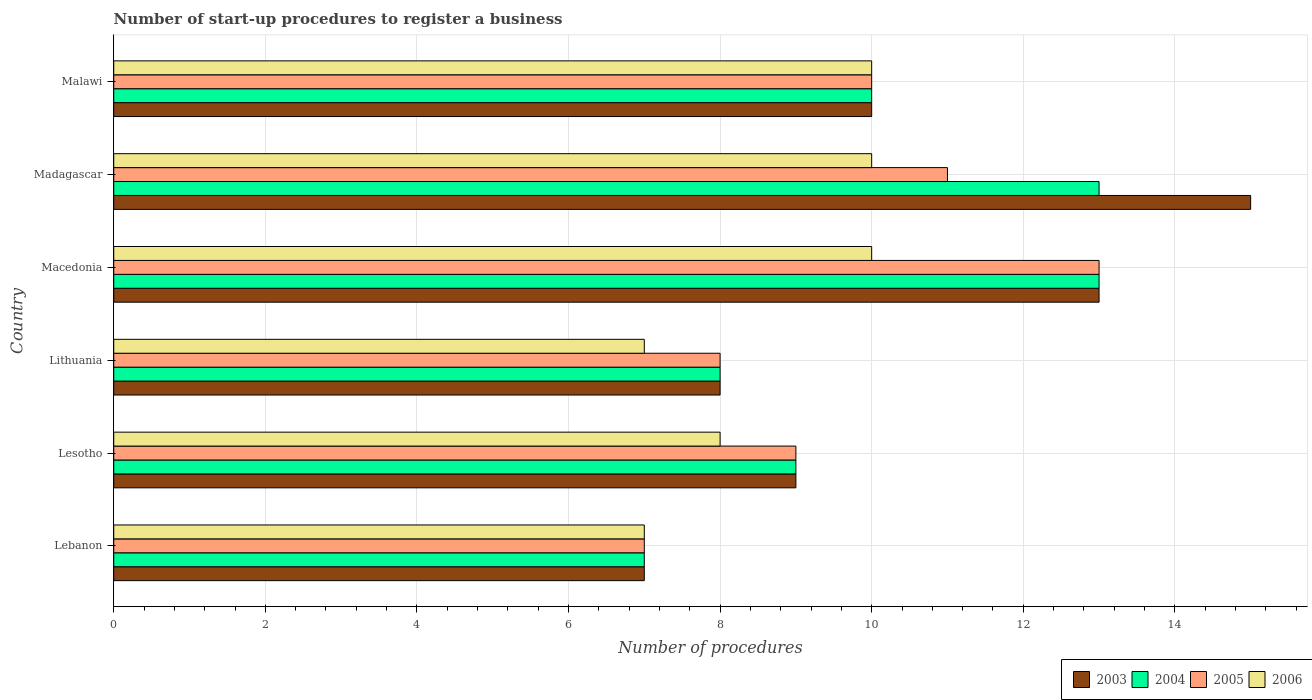How many groups of bars are there?
Your answer should be compact. 6. Are the number of bars per tick equal to the number of legend labels?
Give a very brief answer. Yes. How many bars are there on the 3rd tick from the top?
Your response must be concise. 4. How many bars are there on the 2nd tick from the bottom?
Give a very brief answer. 4. What is the label of the 3rd group of bars from the top?
Give a very brief answer. Macedonia. In how many cases, is the number of bars for a given country not equal to the number of legend labels?
Your response must be concise. 0. Across all countries, what is the minimum number of procedures required to register a business in 2005?
Offer a terse response. 7. In which country was the number of procedures required to register a business in 2005 maximum?
Keep it short and to the point. Macedonia. In which country was the number of procedures required to register a business in 2003 minimum?
Your answer should be very brief. Lebanon. What is the difference between the number of procedures required to register a business in 2003 in Lithuania and that in Madagascar?
Give a very brief answer. -7. What is the average number of procedures required to register a business in 2005 per country?
Provide a succinct answer. 9.67. What is the ratio of the number of procedures required to register a business in 2004 in Macedonia to that in Madagascar?
Ensure brevity in your answer.  1. Is the number of procedures required to register a business in 2004 in Lebanon less than that in Madagascar?
Give a very brief answer. Yes. Is the difference between the number of procedures required to register a business in 2004 in Lithuania and Macedonia greater than the difference between the number of procedures required to register a business in 2005 in Lithuania and Macedonia?
Ensure brevity in your answer.  No. What is the difference between the highest and the lowest number of procedures required to register a business in 2006?
Your answer should be compact. 3. Is the sum of the number of procedures required to register a business in 2004 in Lebanon and Macedonia greater than the maximum number of procedures required to register a business in 2005 across all countries?
Keep it short and to the point. Yes. What does the 2nd bar from the bottom in Lithuania represents?
Make the answer very short. 2004. Is it the case that in every country, the sum of the number of procedures required to register a business in 2005 and number of procedures required to register a business in 2004 is greater than the number of procedures required to register a business in 2006?
Give a very brief answer. Yes. Are all the bars in the graph horizontal?
Offer a terse response. Yes. What is the difference between two consecutive major ticks on the X-axis?
Offer a very short reply. 2. How are the legend labels stacked?
Ensure brevity in your answer.  Horizontal. What is the title of the graph?
Keep it short and to the point. Number of start-up procedures to register a business. What is the label or title of the X-axis?
Ensure brevity in your answer.  Number of procedures. What is the Number of procedures in 2004 in Lebanon?
Provide a succinct answer. 7. What is the Number of procedures of 2005 in Lebanon?
Your answer should be compact. 7. What is the Number of procedures of 2006 in Lebanon?
Provide a succinct answer. 7. What is the Number of procedures of 2006 in Lesotho?
Offer a terse response. 8. What is the Number of procedures of 2003 in Lithuania?
Provide a short and direct response. 8. What is the Number of procedures in 2006 in Lithuania?
Give a very brief answer. 7. What is the Number of procedures in 2004 in Macedonia?
Your answer should be compact. 13. What is the Number of procedures in 2005 in Macedonia?
Provide a succinct answer. 13. What is the Number of procedures in 2004 in Madagascar?
Ensure brevity in your answer.  13. What is the Number of procedures of 2005 in Malawi?
Ensure brevity in your answer.  10. Across all countries, what is the maximum Number of procedures in 2003?
Ensure brevity in your answer.  15. Across all countries, what is the maximum Number of procedures of 2004?
Ensure brevity in your answer.  13. Across all countries, what is the maximum Number of procedures in 2006?
Offer a terse response. 10. Across all countries, what is the minimum Number of procedures in 2003?
Your response must be concise. 7. Across all countries, what is the minimum Number of procedures in 2004?
Give a very brief answer. 7. Across all countries, what is the minimum Number of procedures of 2006?
Provide a succinct answer. 7. What is the total Number of procedures of 2004 in the graph?
Offer a very short reply. 60. What is the total Number of procedures of 2005 in the graph?
Ensure brevity in your answer.  58. What is the total Number of procedures in 2006 in the graph?
Ensure brevity in your answer.  52. What is the difference between the Number of procedures of 2003 in Lebanon and that in Lesotho?
Make the answer very short. -2. What is the difference between the Number of procedures of 2005 in Lebanon and that in Lesotho?
Provide a succinct answer. -2. What is the difference between the Number of procedures in 2006 in Lebanon and that in Lesotho?
Your response must be concise. -1. What is the difference between the Number of procedures of 2004 in Lebanon and that in Lithuania?
Keep it short and to the point. -1. What is the difference between the Number of procedures of 2005 in Lebanon and that in Lithuania?
Make the answer very short. -1. What is the difference between the Number of procedures of 2006 in Lebanon and that in Lithuania?
Offer a terse response. 0. What is the difference between the Number of procedures of 2003 in Lebanon and that in Macedonia?
Your answer should be very brief. -6. What is the difference between the Number of procedures in 2004 in Lebanon and that in Macedonia?
Offer a very short reply. -6. What is the difference between the Number of procedures in 2003 in Lebanon and that in Madagascar?
Make the answer very short. -8. What is the difference between the Number of procedures in 2005 in Lebanon and that in Madagascar?
Make the answer very short. -4. What is the difference between the Number of procedures of 2006 in Lebanon and that in Madagascar?
Provide a short and direct response. -3. What is the difference between the Number of procedures of 2003 in Lebanon and that in Malawi?
Keep it short and to the point. -3. What is the difference between the Number of procedures of 2003 in Lesotho and that in Lithuania?
Provide a short and direct response. 1. What is the difference between the Number of procedures of 2003 in Lesotho and that in Macedonia?
Keep it short and to the point. -4. What is the difference between the Number of procedures of 2004 in Lesotho and that in Macedonia?
Give a very brief answer. -4. What is the difference between the Number of procedures in 2005 in Lesotho and that in Macedonia?
Your answer should be very brief. -4. What is the difference between the Number of procedures in 2006 in Lesotho and that in Macedonia?
Offer a terse response. -2. What is the difference between the Number of procedures of 2003 in Lesotho and that in Madagascar?
Your answer should be very brief. -6. What is the difference between the Number of procedures of 2004 in Lesotho and that in Madagascar?
Provide a short and direct response. -4. What is the difference between the Number of procedures in 2005 in Lesotho and that in Madagascar?
Ensure brevity in your answer.  -2. What is the difference between the Number of procedures of 2004 in Lesotho and that in Malawi?
Keep it short and to the point. -1. What is the difference between the Number of procedures of 2003 in Lithuania and that in Macedonia?
Provide a short and direct response. -5. What is the difference between the Number of procedures in 2004 in Lithuania and that in Macedonia?
Offer a very short reply. -5. What is the difference between the Number of procedures of 2003 in Lithuania and that in Madagascar?
Make the answer very short. -7. What is the difference between the Number of procedures of 2004 in Lithuania and that in Madagascar?
Keep it short and to the point. -5. What is the difference between the Number of procedures of 2005 in Lithuania and that in Madagascar?
Make the answer very short. -3. What is the difference between the Number of procedures of 2006 in Lithuania and that in Madagascar?
Your response must be concise. -3. What is the difference between the Number of procedures of 2003 in Lithuania and that in Malawi?
Provide a short and direct response. -2. What is the difference between the Number of procedures in 2004 in Lithuania and that in Malawi?
Provide a succinct answer. -2. What is the difference between the Number of procedures in 2005 in Lithuania and that in Malawi?
Your answer should be compact. -2. What is the difference between the Number of procedures in 2006 in Lithuania and that in Malawi?
Offer a very short reply. -3. What is the difference between the Number of procedures of 2005 in Macedonia and that in Madagascar?
Your answer should be compact. 2. What is the difference between the Number of procedures in 2004 in Macedonia and that in Malawi?
Offer a very short reply. 3. What is the difference between the Number of procedures of 2006 in Macedonia and that in Malawi?
Make the answer very short. 0. What is the difference between the Number of procedures in 2004 in Madagascar and that in Malawi?
Ensure brevity in your answer.  3. What is the difference between the Number of procedures in 2006 in Madagascar and that in Malawi?
Make the answer very short. 0. What is the difference between the Number of procedures in 2003 in Lebanon and the Number of procedures in 2005 in Lesotho?
Give a very brief answer. -2. What is the difference between the Number of procedures in 2005 in Lebanon and the Number of procedures in 2006 in Lesotho?
Provide a succinct answer. -1. What is the difference between the Number of procedures in 2003 in Lebanon and the Number of procedures in 2004 in Lithuania?
Your response must be concise. -1. What is the difference between the Number of procedures of 2003 in Lebanon and the Number of procedures of 2005 in Lithuania?
Ensure brevity in your answer.  -1. What is the difference between the Number of procedures of 2004 in Lebanon and the Number of procedures of 2005 in Lithuania?
Provide a succinct answer. -1. What is the difference between the Number of procedures in 2004 in Lebanon and the Number of procedures in 2006 in Macedonia?
Ensure brevity in your answer.  -3. What is the difference between the Number of procedures in 2003 in Lebanon and the Number of procedures in 2004 in Madagascar?
Your answer should be compact. -6. What is the difference between the Number of procedures in 2003 in Lebanon and the Number of procedures in 2006 in Madagascar?
Provide a succinct answer. -3. What is the difference between the Number of procedures of 2004 in Lebanon and the Number of procedures of 2006 in Madagascar?
Your answer should be compact. -3. What is the difference between the Number of procedures in 2005 in Lebanon and the Number of procedures in 2006 in Madagascar?
Provide a succinct answer. -3. What is the difference between the Number of procedures of 2003 in Lebanon and the Number of procedures of 2004 in Malawi?
Make the answer very short. -3. What is the difference between the Number of procedures of 2005 in Lebanon and the Number of procedures of 2006 in Malawi?
Give a very brief answer. -3. What is the difference between the Number of procedures in 2003 in Lesotho and the Number of procedures in 2005 in Lithuania?
Give a very brief answer. 1. What is the difference between the Number of procedures of 2003 in Lesotho and the Number of procedures of 2006 in Lithuania?
Your answer should be very brief. 2. What is the difference between the Number of procedures of 2004 in Lesotho and the Number of procedures of 2005 in Lithuania?
Give a very brief answer. 1. What is the difference between the Number of procedures in 2005 in Lesotho and the Number of procedures in 2006 in Lithuania?
Make the answer very short. 2. What is the difference between the Number of procedures of 2003 in Lesotho and the Number of procedures of 2004 in Macedonia?
Your response must be concise. -4. What is the difference between the Number of procedures in 2003 in Lesotho and the Number of procedures in 2005 in Macedonia?
Keep it short and to the point. -4. What is the difference between the Number of procedures in 2003 in Lesotho and the Number of procedures in 2006 in Macedonia?
Ensure brevity in your answer.  -1. What is the difference between the Number of procedures in 2004 in Lesotho and the Number of procedures in 2006 in Macedonia?
Give a very brief answer. -1. What is the difference between the Number of procedures of 2003 in Lesotho and the Number of procedures of 2004 in Madagascar?
Provide a short and direct response. -4. What is the difference between the Number of procedures in 2003 in Lesotho and the Number of procedures in 2005 in Madagascar?
Ensure brevity in your answer.  -2. What is the difference between the Number of procedures in 2003 in Lesotho and the Number of procedures in 2006 in Madagascar?
Your answer should be very brief. -1. What is the difference between the Number of procedures of 2003 in Lesotho and the Number of procedures of 2004 in Malawi?
Offer a very short reply. -1. What is the difference between the Number of procedures in 2003 in Lesotho and the Number of procedures in 2005 in Malawi?
Provide a succinct answer. -1. What is the difference between the Number of procedures in 2003 in Lesotho and the Number of procedures in 2006 in Malawi?
Your response must be concise. -1. What is the difference between the Number of procedures of 2003 in Lithuania and the Number of procedures of 2005 in Macedonia?
Keep it short and to the point. -5. What is the difference between the Number of procedures in 2003 in Lithuania and the Number of procedures in 2006 in Macedonia?
Give a very brief answer. -2. What is the difference between the Number of procedures in 2005 in Lithuania and the Number of procedures in 2006 in Macedonia?
Make the answer very short. -2. What is the difference between the Number of procedures in 2003 in Lithuania and the Number of procedures in 2004 in Madagascar?
Offer a terse response. -5. What is the difference between the Number of procedures of 2004 in Lithuania and the Number of procedures of 2005 in Madagascar?
Offer a very short reply. -3. What is the difference between the Number of procedures of 2005 in Lithuania and the Number of procedures of 2006 in Madagascar?
Give a very brief answer. -2. What is the difference between the Number of procedures in 2003 in Lithuania and the Number of procedures in 2005 in Malawi?
Your response must be concise. -2. What is the difference between the Number of procedures in 2003 in Lithuania and the Number of procedures in 2006 in Malawi?
Keep it short and to the point. -2. What is the difference between the Number of procedures in 2004 in Lithuania and the Number of procedures in 2005 in Malawi?
Provide a succinct answer. -2. What is the difference between the Number of procedures in 2004 in Lithuania and the Number of procedures in 2006 in Malawi?
Offer a terse response. -2. What is the difference between the Number of procedures of 2005 in Lithuania and the Number of procedures of 2006 in Malawi?
Your answer should be very brief. -2. What is the difference between the Number of procedures of 2003 in Macedonia and the Number of procedures of 2004 in Madagascar?
Your answer should be compact. 0. What is the difference between the Number of procedures of 2004 in Macedonia and the Number of procedures of 2005 in Madagascar?
Provide a short and direct response. 2. What is the difference between the Number of procedures of 2003 in Macedonia and the Number of procedures of 2006 in Malawi?
Provide a short and direct response. 3. What is the difference between the Number of procedures in 2004 in Macedonia and the Number of procedures in 2006 in Malawi?
Provide a succinct answer. 3. What is the difference between the Number of procedures of 2003 in Madagascar and the Number of procedures of 2006 in Malawi?
Keep it short and to the point. 5. What is the difference between the Number of procedures in 2005 in Madagascar and the Number of procedures in 2006 in Malawi?
Ensure brevity in your answer.  1. What is the average Number of procedures in 2003 per country?
Offer a terse response. 10.33. What is the average Number of procedures in 2004 per country?
Offer a terse response. 10. What is the average Number of procedures in 2005 per country?
Make the answer very short. 9.67. What is the average Number of procedures in 2006 per country?
Offer a terse response. 8.67. What is the difference between the Number of procedures in 2003 and Number of procedures in 2004 in Lebanon?
Your response must be concise. 0. What is the difference between the Number of procedures of 2004 and Number of procedures of 2005 in Lebanon?
Give a very brief answer. 0. What is the difference between the Number of procedures of 2004 and Number of procedures of 2006 in Lebanon?
Your answer should be compact. 0. What is the difference between the Number of procedures in 2003 and Number of procedures in 2005 in Lesotho?
Provide a short and direct response. 0. What is the difference between the Number of procedures in 2003 and Number of procedures in 2006 in Lesotho?
Your answer should be compact. 1. What is the difference between the Number of procedures of 2004 and Number of procedures of 2005 in Lesotho?
Give a very brief answer. 0. What is the difference between the Number of procedures in 2005 and Number of procedures in 2006 in Lesotho?
Ensure brevity in your answer.  1. What is the difference between the Number of procedures of 2003 and Number of procedures of 2005 in Lithuania?
Keep it short and to the point. 0. What is the difference between the Number of procedures of 2004 and Number of procedures of 2005 in Lithuania?
Ensure brevity in your answer.  0. What is the difference between the Number of procedures in 2003 and Number of procedures in 2004 in Macedonia?
Offer a terse response. 0. What is the difference between the Number of procedures of 2004 and Number of procedures of 2006 in Macedonia?
Your answer should be compact. 3. What is the difference between the Number of procedures in 2003 and Number of procedures in 2005 in Madagascar?
Offer a terse response. 4. What is the difference between the Number of procedures in 2004 and Number of procedures in 2005 in Madagascar?
Offer a very short reply. 2. What is the difference between the Number of procedures in 2004 and Number of procedures in 2006 in Madagascar?
Make the answer very short. 3. What is the difference between the Number of procedures in 2003 and Number of procedures in 2004 in Malawi?
Keep it short and to the point. 0. What is the difference between the Number of procedures in 2004 and Number of procedures in 2006 in Malawi?
Your response must be concise. 0. What is the difference between the Number of procedures in 2005 and Number of procedures in 2006 in Malawi?
Keep it short and to the point. 0. What is the ratio of the Number of procedures in 2003 in Lebanon to that in Lesotho?
Provide a short and direct response. 0.78. What is the ratio of the Number of procedures of 2003 in Lebanon to that in Lithuania?
Ensure brevity in your answer.  0.88. What is the ratio of the Number of procedures in 2004 in Lebanon to that in Lithuania?
Offer a very short reply. 0.88. What is the ratio of the Number of procedures of 2005 in Lebanon to that in Lithuania?
Make the answer very short. 0.88. What is the ratio of the Number of procedures in 2003 in Lebanon to that in Macedonia?
Offer a terse response. 0.54. What is the ratio of the Number of procedures in 2004 in Lebanon to that in Macedonia?
Your response must be concise. 0.54. What is the ratio of the Number of procedures in 2005 in Lebanon to that in Macedonia?
Provide a succinct answer. 0.54. What is the ratio of the Number of procedures of 2003 in Lebanon to that in Madagascar?
Keep it short and to the point. 0.47. What is the ratio of the Number of procedures of 2004 in Lebanon to that in Madagascar?
Provide a short and direct response. 0.54. What is the ratio of the Number of procedures in 2005 in Lebanon to that in Madagascar?
Offer a terse response. 0.64. What is the ratio of the Number of procedures in 2006 in Lebanon to that in Madagascar?
Your answer should be compact. 0.7. What is the ratio of the Number of procedures of 2003 in Lebanon to that in Malawi?
Your response must be concise. 0.7. What is the ratio of the Number of procedures in 2005 in Lebanon to that in Malawi?
Offer a very short reply. 0.7. What is the ratio of the Number of procedures in 2006 in Lebanon to that in Malawi?
Provide a succinct answer. 0.7. What is the ratio of the Number of procedures of 2004 in Lesotho to that in Lithuania?
Provide a succinct answer. 1.12. What is the ratio of the Number of procedures of 2005 in Lesotho to that in Lithuania?
Provide a short and direct response. 1.12. What is the ratio of the Number of procedures of 2006 in Lesotho to that in Lithuania?
Give a very brief answer. 1.14. What is the ratio of the Number of procedures in 2003 in Lesotho to that in Macedonia?
Your response must be concise. 0.69. What is the ratio of the Number of procedures in 2004 in Lesotho to that in Macedonia?
Provide a short and direct response. 0.69. What is the ratio of the Number of procedures in 2005 in Lesotho to that in Macedonia?
Give a very brief answer. 0.69. What is the ratio of the Number of procedures in 2004 in Lesotho to that in Madagascar?
Your response must be concise. 0.69. What is the ratio of the Number of procedures of 2005 in Lesotho to that in Madagascar?
Your answer should be very brief. 0.82. What is the ratio of the Number of procedures of 2006 in Lesotho to that in Madagascar?
Your answer should be very brief. 0.8. What is the ratio of the Number of procedures in 2003 in Lesotho to that in Malawi?
Your response must be concise. 0.9. What is the ratio of the Number of procedures of 2005 in Lesotho to that in Malawi?
Your answer should be very brief. 0.9. What is the ratio of the Number of procedures of 2003 in Lithuania to that in Macedonia?
Offer a very short reply. 0.62. What is the ratio of the Number of procedures in 2004 in Lithuania to that in Macedonia?
Make the answer very short. 0.62. What is the ratio of the Number of procedures of 2005 in Lithuania to that in Macedonia?
Keep it short and to the point. 0.62. What is the ratio of the Number of procedures of 2003 in Lithuania to that in Madagascar?
Your response must be concise. 0.53. What is the ratio of the Number of procedures in 2004 in Lithuania to that in Madagascar?
Your answer should be very brief. 0.62. What is the ratio of the Number of procedures of 2005 in Lithuania to that in Madagascar?
Keep it short and to the point. 0.73. What is the ratio of the Number of procedures in 2006 in Lithuania to that in Madagascar?
Your answer should be compact. 0.7. What is the ratio of the Number of procedures of 2003 in Lithuania to that in Malawi?
Give a very brief answer. 0.8. What is the ratio of the Number of procedures in 2004 in Lithuania to that in Malawi?
Give a very brief answer. 0.8. What is the ratio of the Number of procedures in 2005 in Lithuania to that in Malawi?
Offer a terse response. 0.8. What is the ratio of the Number of procedures of 2003 in Macedonia to that in Madagascar?
Offer a terse response. 0.87. What is the ratio of the Number of procedures in 2004 in Macedonia to that in Madagascar?
Give a very brief answer. 1. What is the ratio of the Number of procedures in 2005 in Macedonia to that in Madagascar?
Provide a short and direct response. 1.18. What is the ratio of the Number of procedures of 2005 in Macedonia to that in Malawi?
Your response must be concise. 1.3. What is the ratio of the Number of procedures in 2006 in Madagascar to that in Malawi?
Your answer should be very brief. 1. What is the difference between the highest and the second highest Number of procedures of 2003?
Your response must be concise. 2. What is the difference between the highest and the second highest Number of procedures in 2004?
Make the answer very short. 0. What is the difference between the highest and the second highest Number of procedures of 2006?
Make the answer very short. 0. What is the difference between the highest and the lowest Number of procedures of 2004?
Provide a succinct answer. 6. 